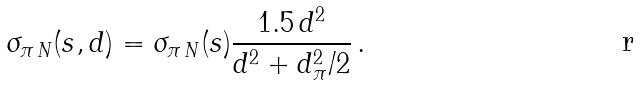Convert formula to latex. <formula><loc_0><loc_0><loc_500><loc_500>\sigma _ { \pi \, N } ( s , d ) = \sigma _ { \pi \, N } ( s ) \frac { 1 . 5 \, d ^ { 2 } } { d ^ { 2 } + d _ { \pi } ^ { 2 } / 2 } \, .</formula> 